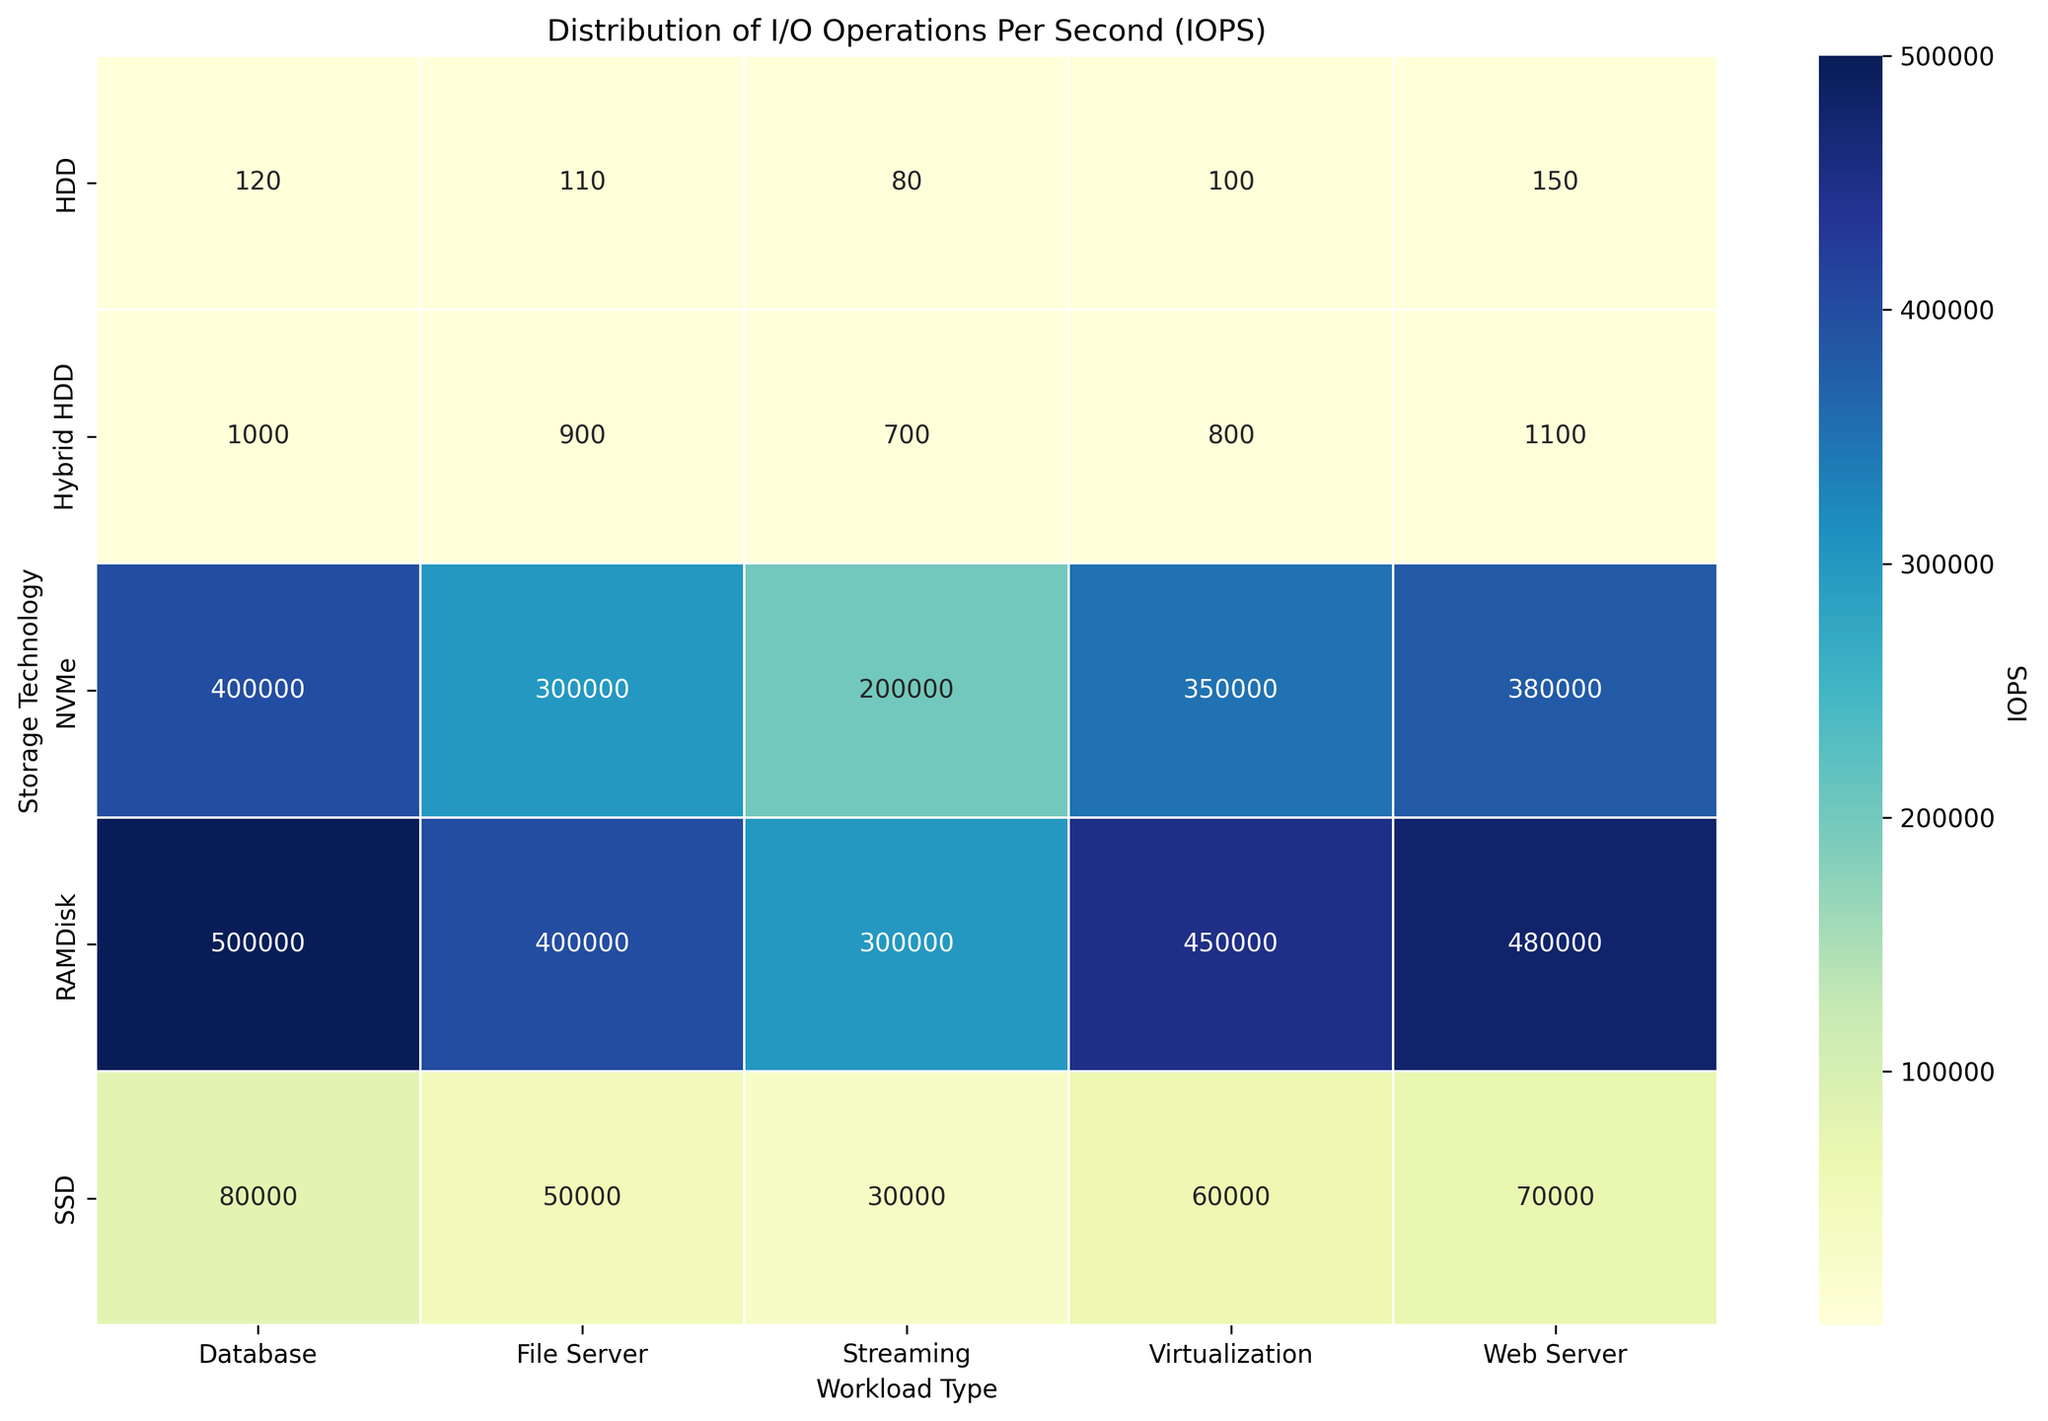What is the maximum IOPS value observed in the figure, and which storage technology and workload type does it correspond to? The maximum IOPS can be found by identifying the highest number in the heatmap. From the figure, 500000 is the highest value, located at the intersection of "RAMDisk" technology and "Database" workload type.
Answer: 500000, RAMDisk - Database Which storage technology shows the lowest IOPS value, and what is the corresponding workload type? The lowest IOPS can be found by identifying the smallest number in the heatmap. From the figure, the smallest value is 80, which can be found at the intersection of "HDD" technology and "Streaming" workload type.
Answer: 80, HDD - Streaming What is the total IOPS for SSD technology across all workload types? To find this, sum all the IOPS values for SSD across different workload types. The values are 80000, 60000, 50000, 70000, and 30000. Adding these together: 80000 + 60000 + 50000 + 70000 + 30000 = 290000.
Answer: 290000 Which storage technology has higher average IOPS: Hybrid HDD or HDD? First, calculate the average IOPS for both Hybrid HDD and HDD by summing their values and dividing by the number of workload types. 
For HDD: (120 + 100 + 110 + 150 + 80) / 5 = 560 / 5 = 112.
For Hybrid HDD: (1000 + 800 + 900 + 1100 + 700) / 5 = 4500 / 5 = 900.
Compare 112 with 900.
Answer: Hybrid HDD In the context of virtualization workloads, which storage technology exhibits the second-highest IOPS, and what is its value? Examine the "Virtualization" column and identify the second-highest IOPS value. The values are 100, 60000, 350000, 800, and 450000. The highest is 450000 (RAMDisk), and the second highest is 350000 (NVMe).
Answer: 350000, NVMe 